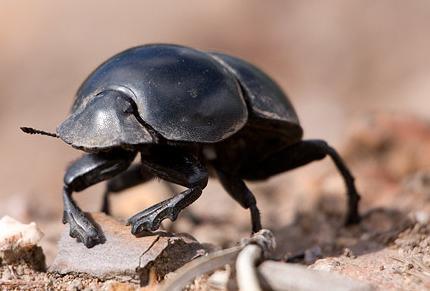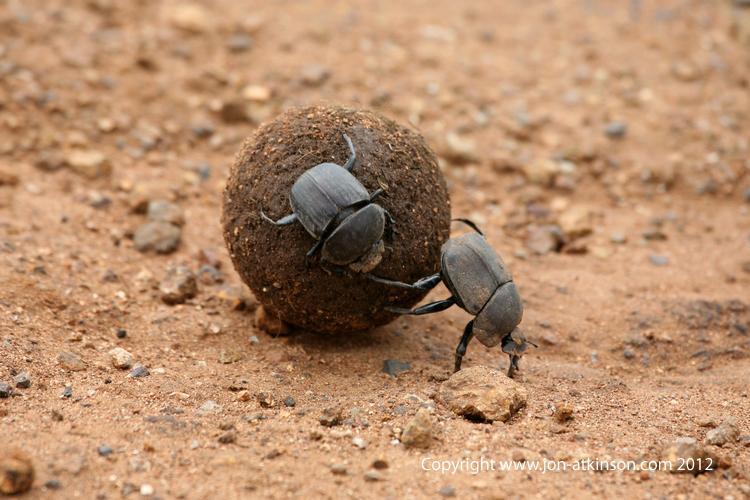The first image is the image on the left, the second image is the image on the right. Considering the images on both sides, is "At least one beetle is in contact with a round, not oblong, ball." valid? Answer yes or no. Yes. 